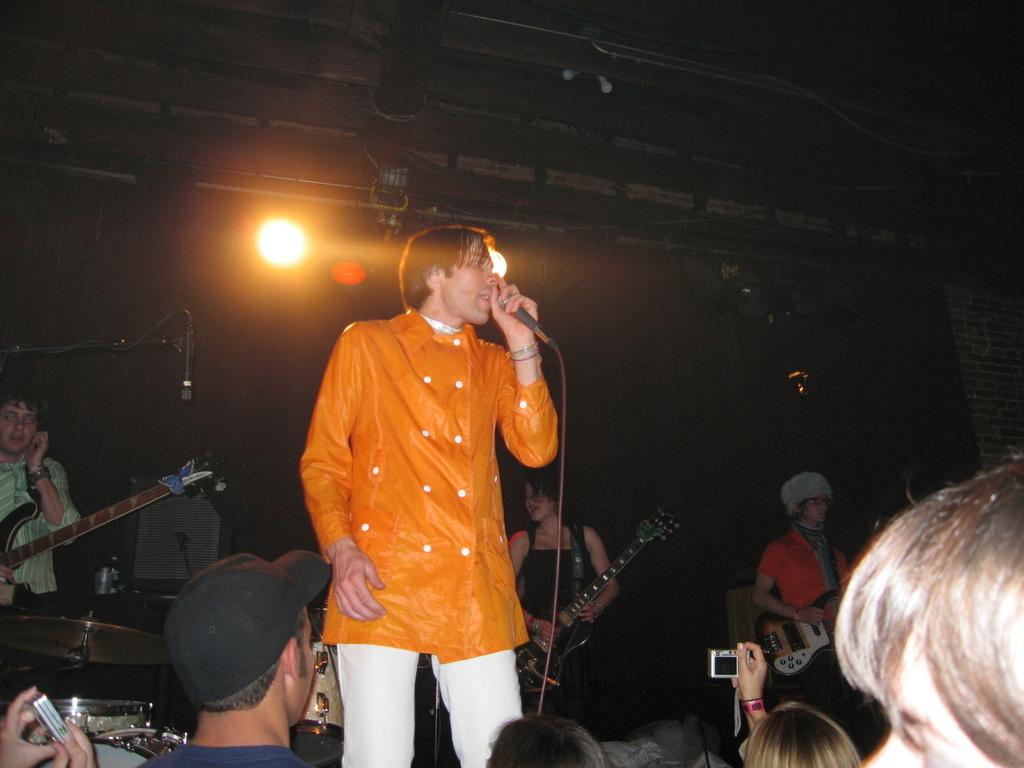How many people are in the image? There is a group of people in the image. What is the person in the front holding? The person in the front is holding a microphone. What type of musical instrument can be seen in the background? There are people playing a guitar in the background. What flavor of ice cream is being advertised in the image? There is no ice cream or advertisement present in the image. 